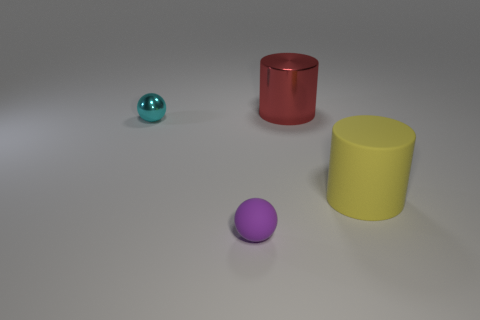Can you describe the different objects and their colors in the image? Certainly! In the image, there are four distinct objects. Moving from left to right, there's a small cyan sphere, a larger red cylinder, a slightly smaller yellow cylinder, and a small purple sphere in the foreground. 